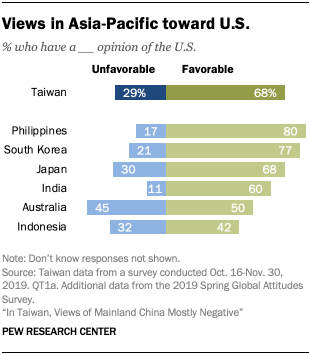Point out several critical features in this image. The lowest value of the blue light blue bar is 11. The product of blue bars in India and Japan is 330. 